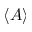<formula> <loc_0><loc_0><loc_500><loc_500>\langle A \rangle</formula> 